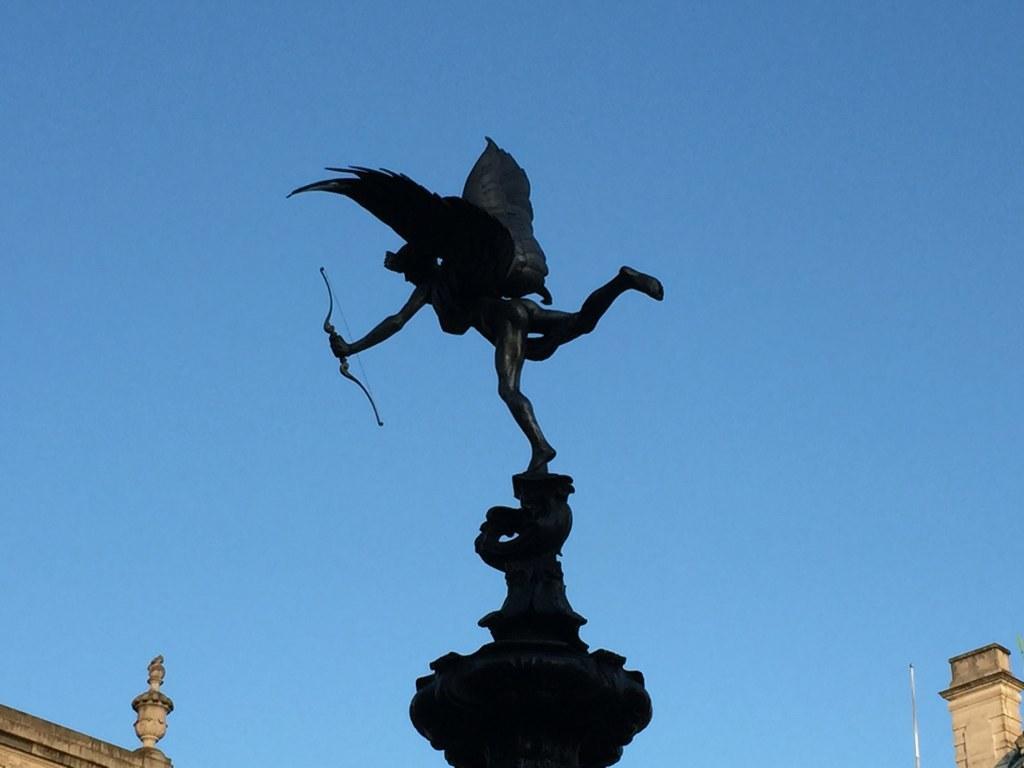In one or two sentences, can you explain what this image depicts? In this picture we can see a statue in the middle, at the left bottom there is a building, we can see a pole and a building at the right bottom, there is the sky at the top of the picture. 